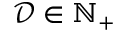<formula> <loc_0><loc_0><loc_500><loc_500>\mathcal { D } \in \mathbb { N } _ { + }</formula> 